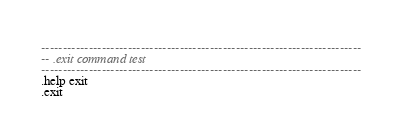Convert code to text. <code><loc_0><loc_0><loc_500><loc_500><_SQL_>--------------------------------------------------------------------------
-- .exit command test
--------------------------------------------------------------------------
.help exit
.exit

</code> 